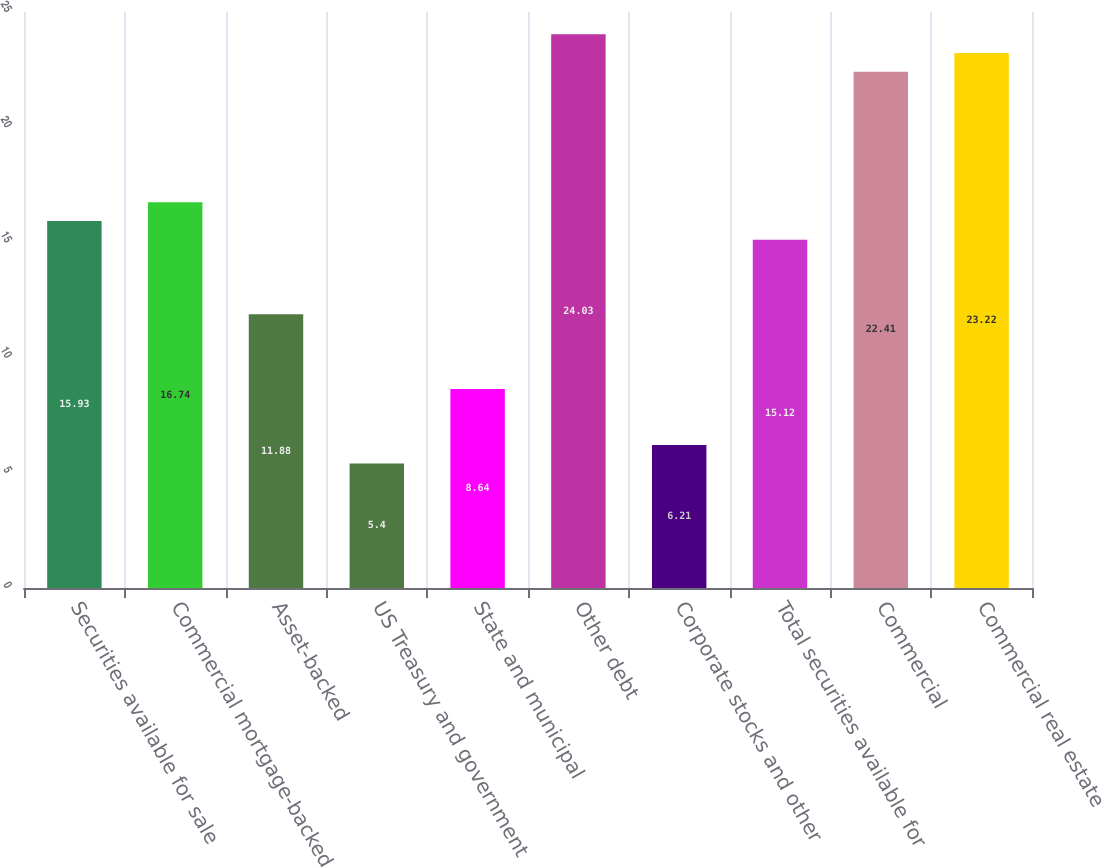Convert chart. <chart><loc_0><loc_0><loc_500><loc_500><bar_chart><fcel>Securities available for sale<fcel>Commercial mortgage-backed<fcel>Asset-backed<fcel>US Treasury and government<fcel>State and municipal<fcel>Other debt<fcel>Corporate stocks and other<fcel>Total securities available for<fcel>Commercial<fcel>Commercial real estate<nl><fcel>15.93<fcel>16.74<fcel>11.88<fcel>5.4<fcel>8.64<fcel>24.03<fcel>6.21<fcel>15.12<fcel>22.41<fcel>23.22<nl></chart> 